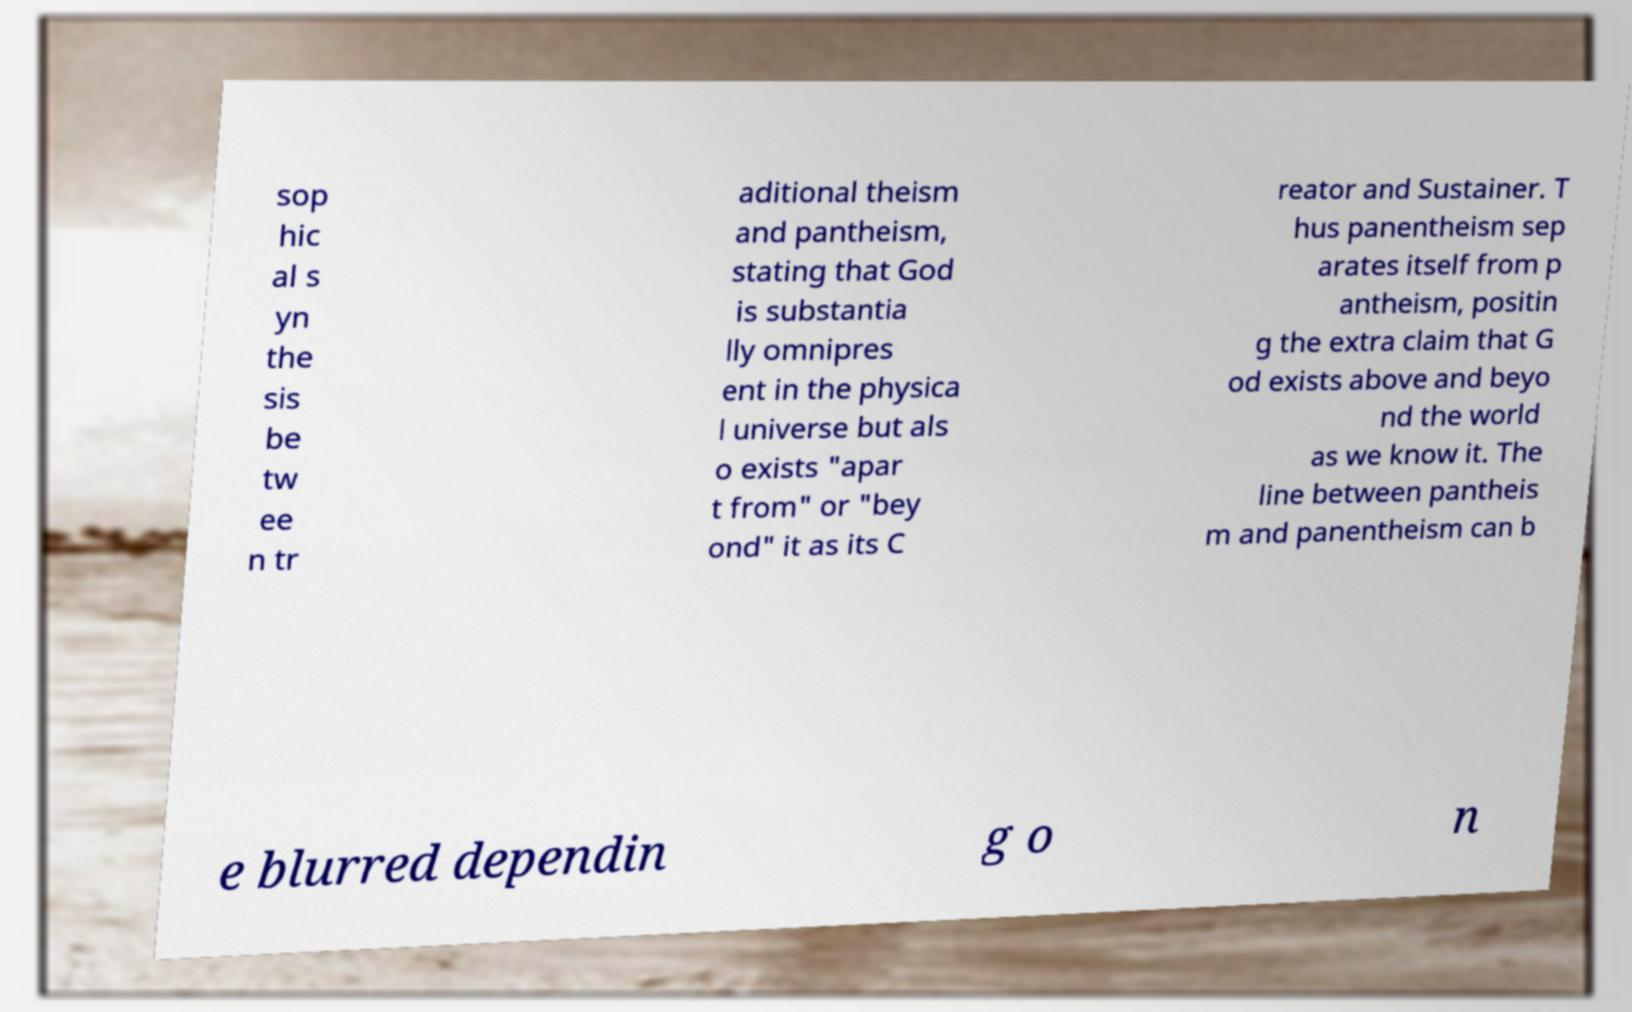Could you assist in decoding the text presented in this image and type it out clearly? sop hic al s yn the sis be tw ee n tr aditional theism and pantheism, stating that God is substantia lly omnipres ent in the physica l universe but als o exists "apar t from" or "bey ond" it as its C reator and Sustainer. T hus panentheism sep arates itself from p antheism, positin g the extra claim that G od exists above and beyo nd the world as we know it. The line between pantheis m and panentheism can b e blurred dependin g o n 